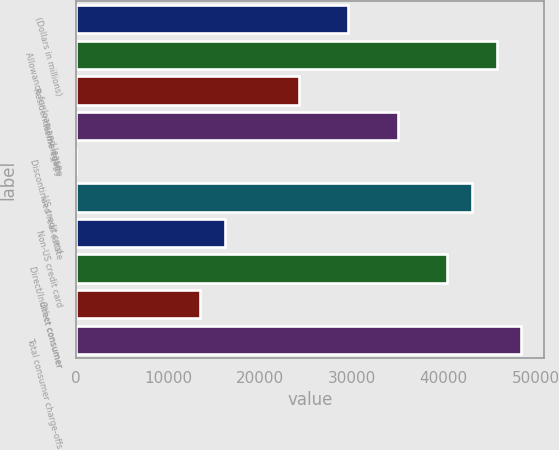<chart> <loc_0><loc_0><loc_500><loc_500><bar_chart><fcel>(Dollars in millions)<fcel>Allowance for loan and lease<fcel>Residential mortgage<fcel>Home equity<fcel>Discontinued real estate<fcel>US credit card<fcel>Non-US credit card<fcel>Direct/Indirect consumer<fcel>Other consumer<fcel>Total consumer charge-offs<nl><fcel>29612.3<fcel>45754.1<fcel>24231.7<fcel>34992.9<fcel>19<fcel>43063.8<fcel>16160.8<fcel>40373.5<fcel>13470.5<fcel>48444.4<nl></chart> 